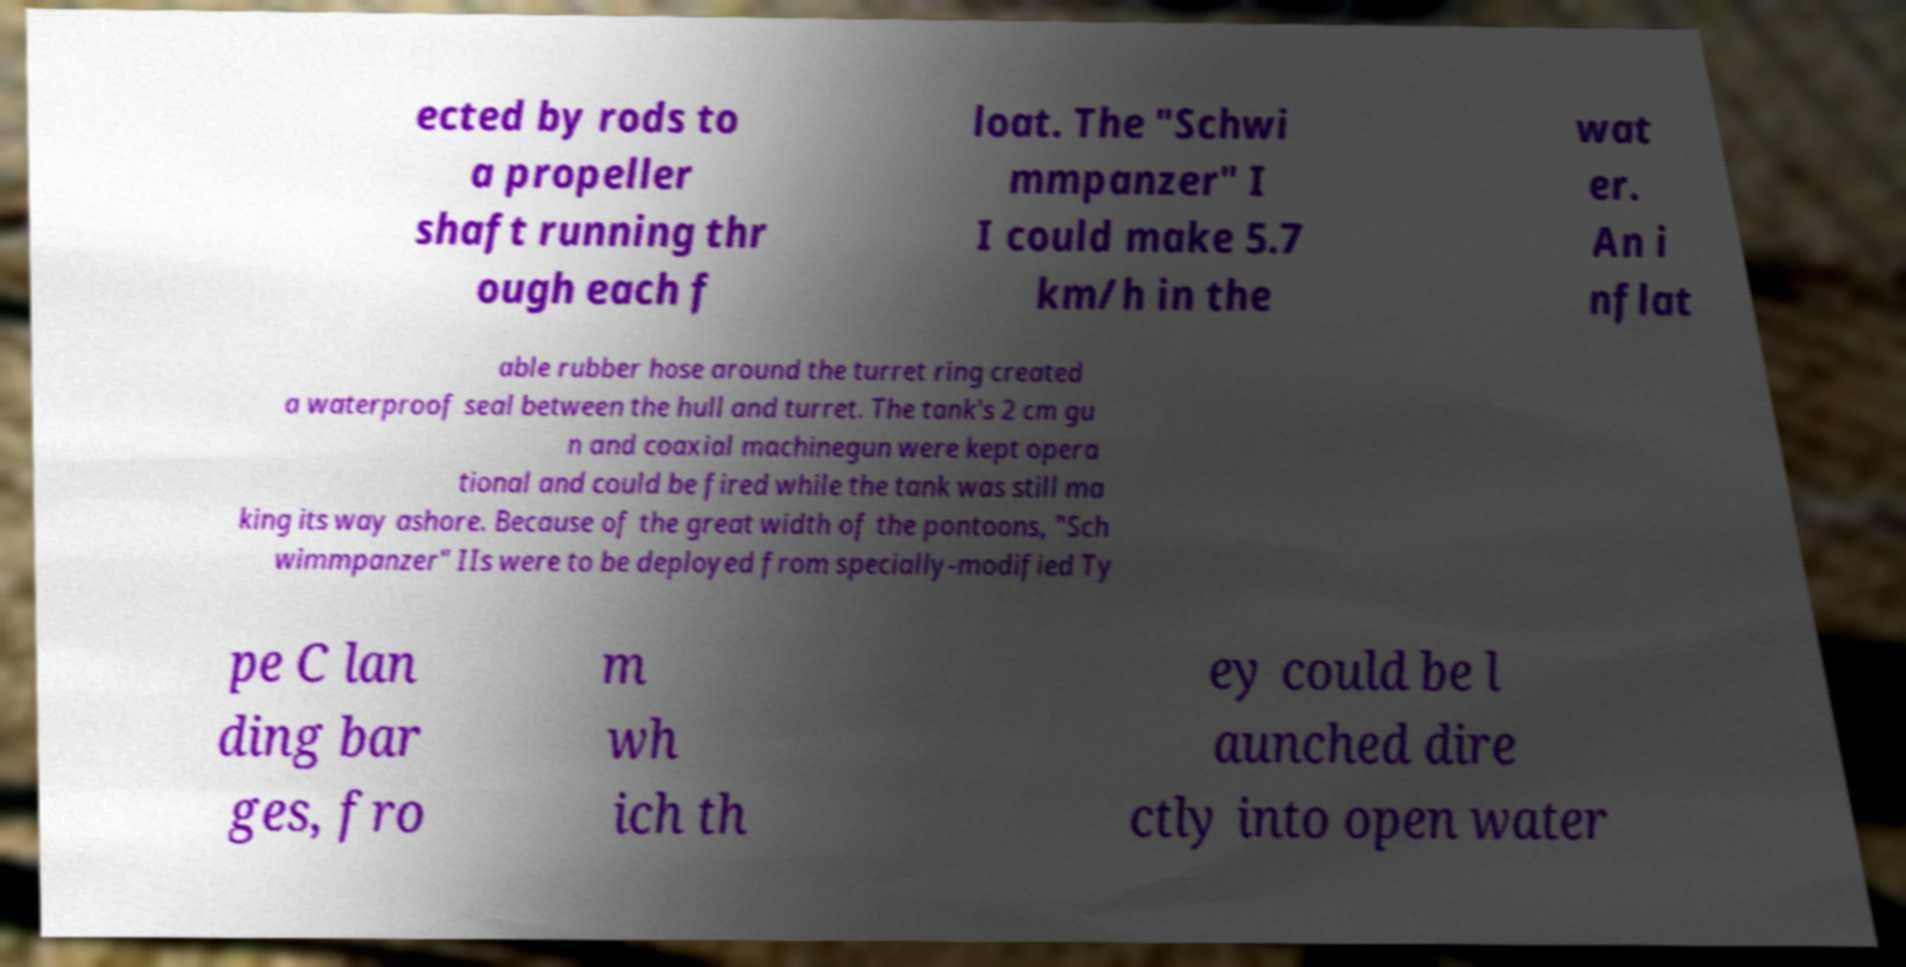I need the written content from this picture converted into text. Can you do that? ected by rods to a propeller shaft running thr ough each f loat. The "Schwi mmpanzer" I I could make 5.7 km/h in the wat er. An i nflat able rubber hose around the turret ring created a waterproof seal between the hull and turret. The tank's 2 cm gu n and coaxial machinegun were kept opera tional and could be fired while the tank was still ma king its way ashore. Because of the great width of the pontoons, "Sch wimmpanzer" IIs were to be deployed from specially-modified Ty pe C lan ding bar ges, fro m wh ich th ey could be l aunched dire ctly into open water 